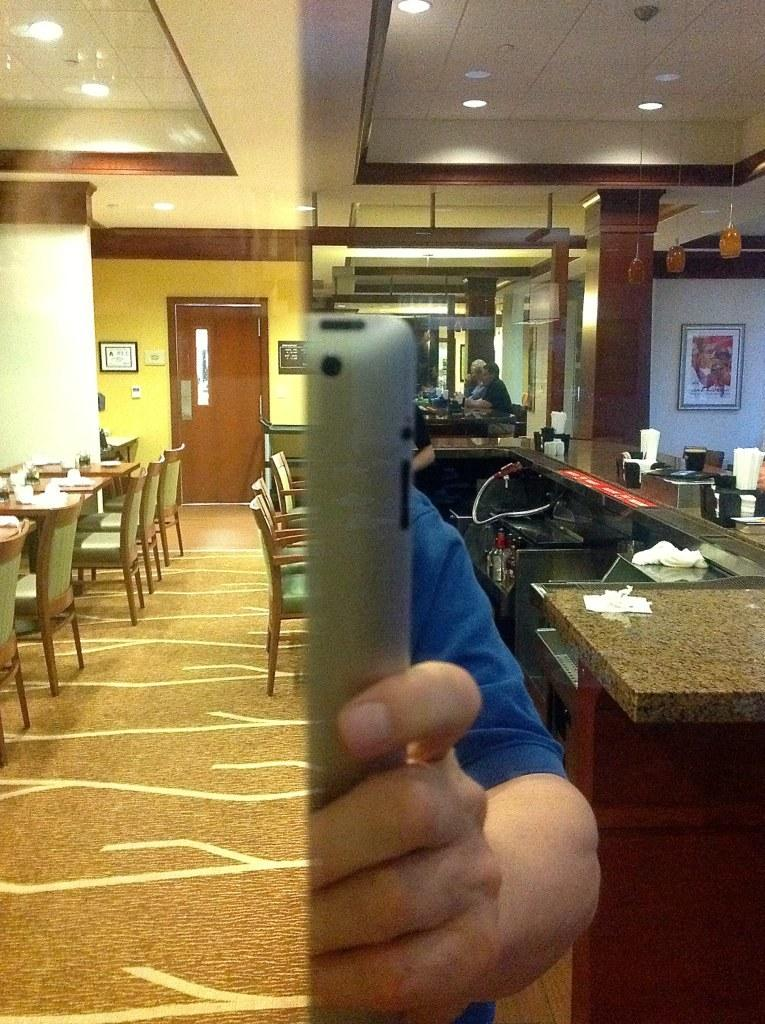How many chairs are visible in the image? There are many chairs in the image. What other furniture can be seen in the image besides chairs? There is a table in the image. What type of surface is shown in the image? This is a floor in the image. What architectural feature is present in the image? There is a door in the image. What part of the door is visible in the image? There is a door frame in the image. What source of light is present in the image? There is a light in the image. What are the people in the image wearing? There are people wearing clothes in the image. What is the taste of the doll in the image? There is no doll present in the image, so it is not possible to determine its taste. 